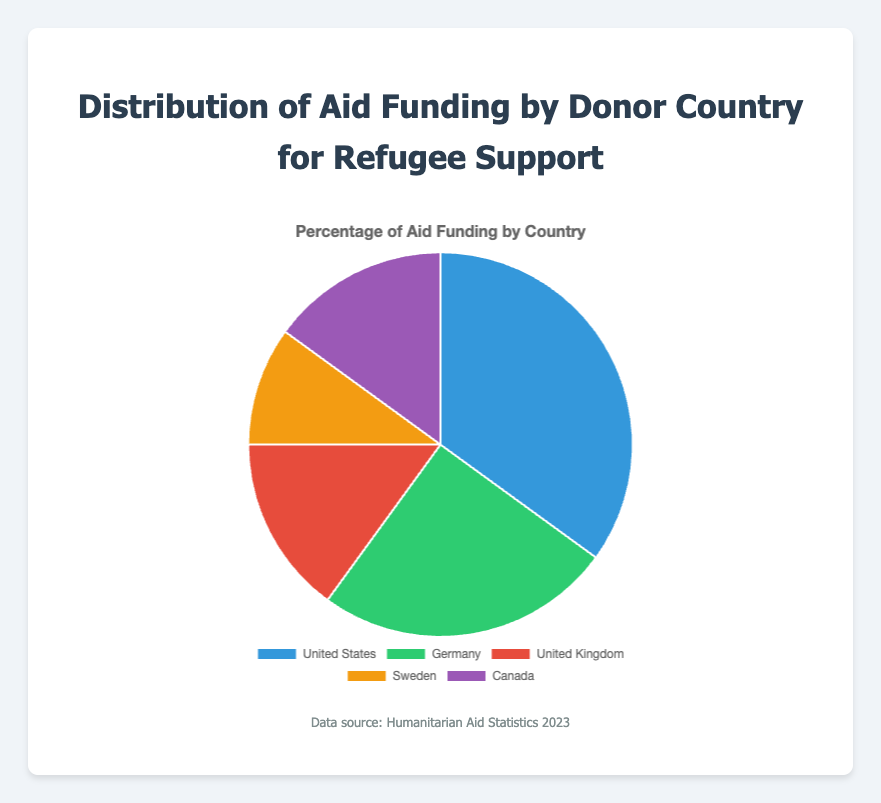What's the most significant donor country by percentage? The United States has the highest percentage of aid funding at 35%. This can be observed directly from the pie chart segment with the largest area.
Answer: United States Which countries provide equal percentages of aid funding? Both the United Kingdom and Canada contribute 15%. By examining the pie chart, you can see two segments of the same size, which are labeled with these countries and their percentages.
Answer: United Kingdom and Canada What's the combined percentage of aid funding coming from the United States and Germany? Add the percentages of the United States (35%) and Germany (25%). 35 + 25 = 60.
Answer: 60% How much more aid funding does the United States provide compared to Sweden? Subtract Sweden's percentage (10%) from the United States' percentage (35%). 35 - 10 = 25.
Answer: 25% Which country contributes the least to aid funding? Sweden provides the smallest percentage at 10%. This is evident from the pie chart segment with the smallest area.
Answer: Sweden What's the average percentage of aid funding provided by all countries? Add all the percentages: 35 + 25 + 15 + 10 + 15 = 100. There are 5 countries. Divide the total by 5. 100 / 5 = 20.
Answer: 20% Is the aid funding from Canada more or less than that from Germany? Canada provides 15%, while Germany provides 25%. Comparing these values, Canada provides less.
Answer: Less What is the visual color representing Germany's aid funding in the chart? Germany’s portion of the pie chart is colored green. This can be determined by matching the country label to its corresponding pie segment.
Answer: Green By how much percentage does the United States' aid funding exceed that of the United Kingdom and Canada combined? First, find the total percentage for the United Kingdom and Canada: 15 + 15 = 30. Subtract this sum from the United States' percentage: 35 - 30 = 5.
Answer: 5% What's the difference in aid funding percentages between Germany and the United Kingdom? Subtract the United Kingdom's percentage (15%) from Germany's percentage (25%). 25 - 15 = 10.
Answer: 10% 